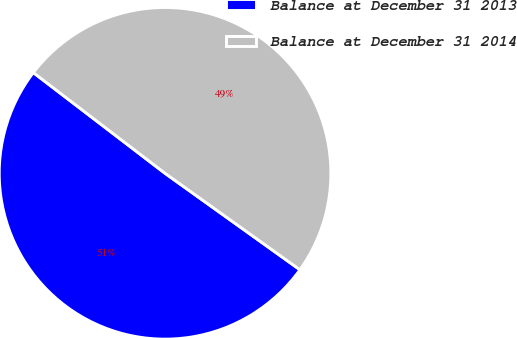<chart> <loc_0><loc_0><loc_500><loc_500><pie_chart><fcel>Balance at December 31 2013<fcel>Balance at December 31 2014<nl><fcel>50.51%<fcel>49.49%<nl></chart> 